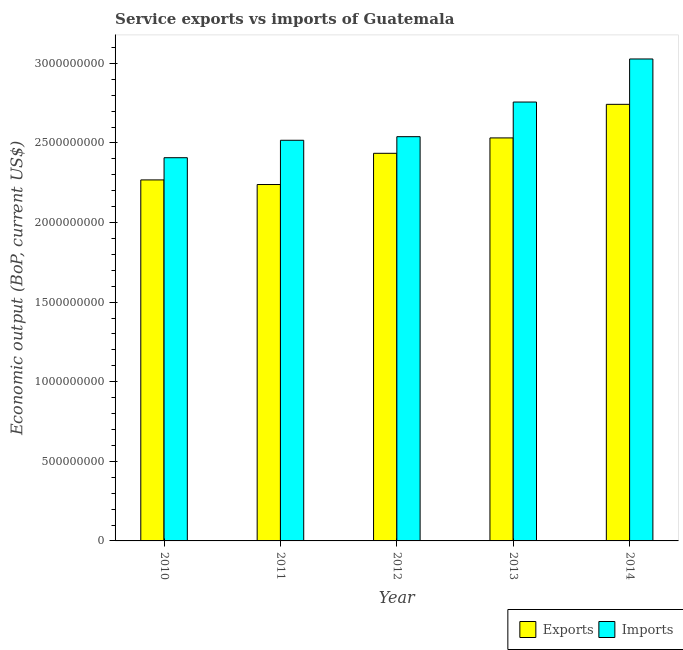How many groups of bars are there?
Offer a terse response. 5. How many bars are there on the 4th tick from the left?
Your answer should be very brief. 2. How many bars are there on the 3rd tick from the right?
Your response must be concise. 2. What is the amount of service imports in 2010?
Give a very brief answer. 2.41e+09. Across all years, what is the maximum amount of service imports?
Offer a very short reply. 3.03e+09. Across all years, what is the minimum amount of service exports?
Provide a short and direct response. 2.24e+09. In which year was the amount of service imports maximum?
Offer a terse response. 2014. In which year was the amount of service exports minimum?
Ensure brevity in your answer.  2011. What is the total amount of service exports in the graph?
Your answer should be very brief. 1.22e+1. What is the difference between the amount of service imports in 2011 and that in 2013?
Provide a short and direct response. -2.40e+08. What is the difference between the amount of service imports in 2013 and the amount of service exports in 2010?
Your answer should be compact. 3.50e+08. What is the average amount of service imports per year?
Your answer should be compact. 2.65e+09. In the year 2014, what is the difference between the amount of service exports and amount of service imports?
Provide a short and direct response. 0. What is the ratio of the amount of service exports in 2012 to that in 2013?
Offer a very short reply. 0.96. Is the difference between the amount of service exports in 2012 and 2013 greater than the difference between the amount of service imports in 2012 and 2013?
Your answer should be compact. No. What is the difference between the highest and the second highest amount of service exports?
Ensure brevity in your answer.  2.11e+08. What is the difference between the highest and the lowest amount of service exports?
Ensure brevity in your answer.  5.04e+08. Is the sum of the amount of service imports in 2012 and 2013 greater than the maximum amount of service exports across all years?
Ensure brevity in your answer.  Yes. What does the 1st bar from the left in 2013 represents?
Provide a short and direct response. Exports. What does the 2nd bar from the right in 2013 represents?
Provide a short and direct response. Exports. Are all the bars in the graph horizontal?
Your response must be concise. No. How many years are there in the graph?
Give a very brief answer. 5. Does the graph contain any zero values?
Your response must be concise. No. How many legend labels are there?
Your response must be concise. 2. How are the legend labels stacked?
Your answer should be compact. Horizontal. What is the title of the graph?
Your answer should be compact. Service exports vs imports of Guatemala. What is the label or title of the Y-axis?
Offer a terse response. Economic output (BoP, current US$). What is the Economic output (BoP, current US$) of Exports in 2010?
Provide a succinct answer. 2.27e+09. What is the Economic output (BoP, current US$) of Imports in 2010?
Make the answer very short. 2.41e+09. What is the Economic output (BoP, current US$) of Exports in 2011?
Your answer should be very brief. 2.24e+09. What is the Economic output (BoP, current US$) in Imports in 2011?
Ensure brevity in your answer.  2.52e+09. What is the Economic output (BoP, current US$) of Exports in 2012?
Your answer should be very brief. 2.43e+09. What is the Economic output (BoP, current US$) of Imports in 2012?
Keep it short and to the point. 2.54e+09. What is the Economic output (BoP, current US$) of Exports in 2013?
Make the answer very short. 2.53e+09. What is the Economic output (BoP, current US$) of Imports in 2013?
Offer a terse response. 2.76e+09. What is the Economic output (BoP, current US$) in Exports in 2014?
Offer a very short reply. 2.74e+09. What is the Economic output (BoP, current US$) of Imports in 2014?
Make the answer very short. 3.03e+09. Across all years, what is the maximum Economic output (BoP, current US$) of Exports?
Give a very brief answer. 2.74e+09. Across all years, what is the maximum Economic output (BoP, current US$) in Imports?
Offer a terse response. 3.03e+09. Across all years, what is the minimum Economic output (BoP, current US$) in Exports?
Offer a very short reply. 2.24e+09. Across all years, what is the minimum Economic output (BoP, current US$) in Imports?
Your answer should be compact. 2.41e+09. What is the total Economic output (BoP, current US$) of Exports in the graph?
Your answer should be compact. 1.22e+1. What is the total Economic output (BoP, current US$) in Imports in the graph?
Your response must be concise. 1.32e+1. What is the difference between the Economic output (BoP, current US$) of Exports in 2010 and that in 2011?
Keep it short and to the point. 2.89e+07. What is the difference between the Economic output (BoP, current US$) of Imports in 2010 and that in 2011?
Keep it short and to the point. -1.10e+08. What is the difference between the Economic output (BoP, current US$) of Exports in 2010 and that in 2012?
Keep it short and to the point. -1.67e+08. What is the difference between the Economic output (BoP, current US$) in Imports in 2010 and that in 2012?
Offer a terse response. -1.32e+08. What is the difference between the Economic output (BoP, current US$) in Exports in 2010 and that in 2013?
Give a very brief answer. -2.64e+08. What is the difference between the Economic output (BoP, current US$) of Imports in 2010 and that in 2013?
Give a very brief answer. -3.50e+08. What is the difference between the Economic output (BoP, current US$) in Exports in 2010 and that in 2014?
Give a very brief answer. -4.75e+08. What is the difference between the Economic output (BoP, current US$) in Imports in 2010 and that in 2014?
Your answer should be compact. -6.20e+08. What is the difference between the Economic output (BoP, current US$) in Exports in 2011 and that in 2012?
Provide a short and direct response. -1.96e+08. What is the difference between the Economic output (BoP, current US$) in Imports in 2011 and that in 2012?
Your response must be concise. -2.26e+07. What is the difference between the Economic output (BoP, current US$) of Exports in 2011 and that in 2013?
Your answer should be compact. -2.93e+08. What is the difference between the Economic output (BoP, current US$) of Imports in 2011 and that in 2013?
Make the answer very short. -2.40e+08. What is the difference between the Economic output (BoP, current US$) of Exports in 2011 and that in 2014?
Give a very brief answer. -5.04e+08. What is the difference between the Economic output (BoP, current US$) of Imports in 2011 and that in 2014?
Provide a short and direct response. -5.11e+08. What is the difference between the Economic output (BoP, current US$) in Exports in 2012 and that in 2013?
Give a very brief answer. -9.67e+07. What is the difference between the Economic output (BoP, current US$) in Imports in 2012 and that in 2013?
Provide a short and direct response. -2.18e+08. What is the difference between the Economic output (BoP, current US$) in Exports in 2012 and that in 2014?
Keep it short and to the point. -3.08e+08. What is the difference between the Economic output (BoP, current US$) in Imports in 2012 and that in 2014?
Keep it short and to the point. -4.88e+08. What is the difference between the Economic output (BoP, current US$) in Exports in 2013 and that in 2014?
Keep it short and to the point. -2.11e+08. What is the difference between the Economic output (BoP, current US$) in Imports in 2013 and that in 2014?
Your answer should be compact. -2.71e+08. What is the difference between the Economic output (BoP, current US$) in Exports in 2010 and the Economic output (BoP, current US$) in Imports in 2011?
Your answer should be very brief. -2.49e+08. What is the difference between the Economic output (BoP, current US$) of Exports in 2010 and the Economic output (BoP, current US$) of Imports in 2012?
Ensure brevity in your answer.  -2.72e+08. What is the difference between the Economic output (BoP, current US$) of Exports in 2010 and the Economic output (BoP, current US$) of Imports in 2013?
Offer a terse response. -4.89e+08. What is the difference between the Economic output (BoP, current US$) of Exports in 2010 and the Economic output (BoP, current US$) of Imports in 2014?
Keep it short and to the point. -7.60e+08. What is the difference between the Economic output (BoP, current US$) of Exports in 2011 and the Economic output (BoP, current US$) of Imports in 2012?
Make the answer very short. -3.01e+08. What is the difference between the Economic output (BoP, current US$) of Exports in 2011 and the Economic output (BoP, current US$) of Imports in 2013?
Provide a succinct answer. -5.18e+08. What is the difference between the Economic output (BoP, current US$) in Exports in 2011 and the Economic output (BoP, current US$) in Imports in 2014?
Offer a very short reply. -7.89e+08. What is the difference between the Economic output (BoP, current US$) of Exports in 2012 and the Economic output (BoP, current US$) of Imports in 2013?
Your response must be concise. -3.22e+08. What is the difference between the Economic output (BoP, current US$) of Exports in 2012 and the Economic output (BoP, current US$) of Imports in 2014?
Your response must be concise. -5.93e+08. What is the difference between the Economic output (BoP, current US$) in Exports in 2013 and the Economic output (BoP, current US$) in Imports in 2014?
Provide a succinct answer. -4.96e+08. What is the average Economic output (BoP, current US$) of Exports per year?
Your answer should be very brief. 2.44e+09. What is the average Economic output (BoP, current US$) of Imports per year?
Give a very brief answer. 2.65e+09. In the year 2010, what is the difference between the Economic output (BoP, current US$) of Exports and Economic output (BoP, current US$) of Imports?
Offer a very short reply. -1.39e+08. In the year 2011, what is the difference between the Economic output (BoP, current US$) in Exports and Economic output (BoP, current US$) in Imports?
Provide a succinct answer. -2.78e+08. In the year 2012, what is the difference between the Economic output (BoP, current US$) in Exports and Economic output (BoP, current US$) in Imports?
Your answer should be compact. -1.04e+08. In the year 2013, what is the difference between the Economic output (BoP, current US$) in Exports and Economic output (BoP, current US$) in Imports?
Your response must be concise. -2.25e+08. In the year 2014, what is the difference between the Economic output (BoP, current US$) in Exports and Economic output (BoP, current US$) in Imports?
Your answer should be compact. -2.85e+08. What is the ratio of the Economic output (BoP, current US$) in Exports in 2010 to that in 2011?
Keep it short and to the point. 1.01. What is the ratio of the Economic output (BoP, current US$) in Imports in 2010 to that in 2011?
Offer a very short reply. 0.96. What is the ratio of the Economic output (BoP, current US$) of Exports in 2010 to that in 2012?
Ensure brevity in your answer.  0.93. What is the ratio of the Economic output (BoP, current US$) in Imports in 2010 to that in 2012?
Give a very brief answer. 0.95. What is the ratio of the Economic output (BoP, current US$) of Exports in 2010 to that in 2013?
Ensure brevity in your answer.  0.9. What is the ratio of the Economic output (BoP, current US$) of Imports in 2010 to that in 2013?
Ensure brevity in your answer.  0.87. What is the ratio of the Economic output (BoP, current US$) of Exports in 2010 to that in 2014?
Your answer should be very brief. 0.83. What is the ratio of the Economic output (BoP, current US$) in Imports in 2010 to that in 2014?
Give a very brief answer. 0.8. What is the ratio of the Economic output (BoP, current US$) in Exports in 2011 to that in 2012?
Your answer should be compact. 0.92. What is the ratio of the Economic output (BoP, current US$) in Exports in 2011 to that in 2013?
Offer a terse response. 0.88. What is the ratio of the Economic output (BoP, current US$) of Imports in 2011 to that in 2013?
Make the answer very short. 0.91. What is the ratio of the Economic output (BoP, current US$) of Exports in 2011 to that in 2014?
Offer a terse response. 0.82. What is the ratio of the Economic output (BoP, current US$) in Imports in 2011 to that in 2014?
Give a very brief answer. 0.83. What is the ratio of the Economic output (BoP, current US$) in Exports in 2012 to that in 2013?
Keep it short and to the point. 0.96. What is the ratio of the Economic output (BoP, current US$) of Imports in 2012 to that in 2013?
Offer a very short reply. 0.92. What is the ratio of the Economic output (BoP, current US$) in Exports in 2012 to that in 2014?
Offer a terse response. 0.89. What is the ratio of the Economic output (BoP, current US$) of Imports in 2012 to that in 2014?
Provide a short and direct response. 0.84. What is the ratio of the Economic output (BoP, current US$) in Imports in 2013 to that in 2014?
Ensure brevity in your answer.  0.91. What is the difference between the highest and the second highest Economic output (BoP, current US$) in Exports?
Your answer should be compact. 2.11e+08. What is the difference between the highest and the second highest Economic output (BoP, current US$) in Imports?
Make the answer very short. 2.71e+08. What is the difference between the highest and the lowest Economic output (BoP, current US$) of Exports?
Your answer should be very brief. 5.04e+08. What is the difference between the highest and the lowest Economic output (BoP, current US$) in Imports?
Provide a succinct answer. 6.20e+08. 